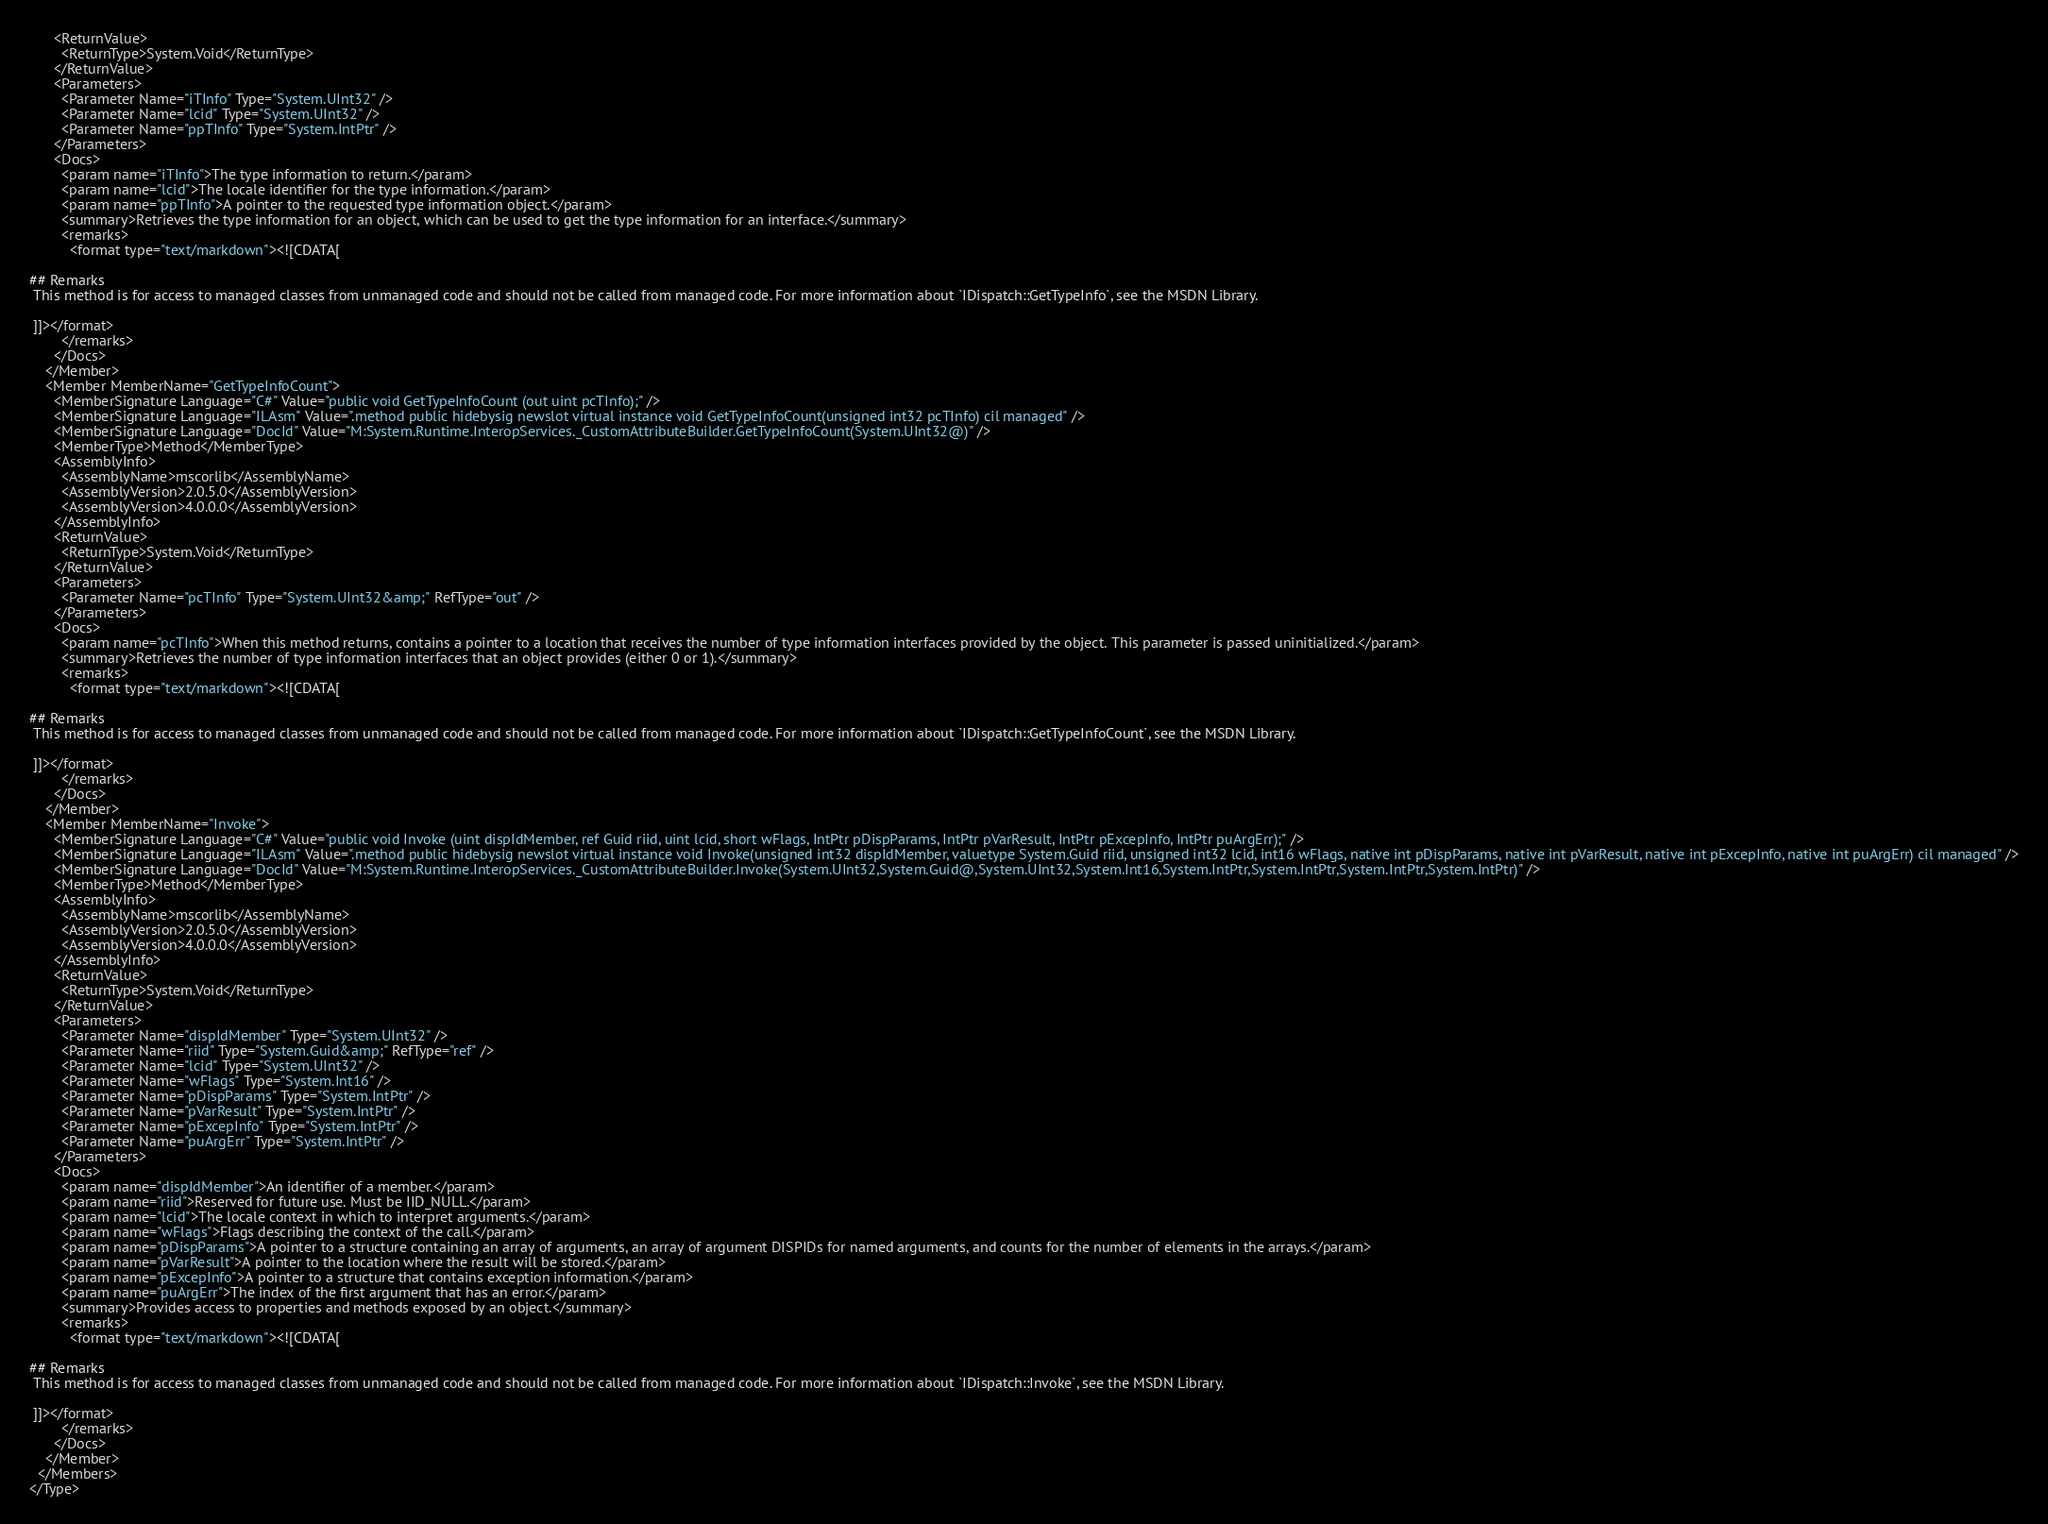Convert code to text. <code><loc_0><loc_0><loc_500><loc_500><_XML_>      <ReturnValue>
        <ReturnType>System.Void</ReturnType>
      </ReturnValue>
      <Parameters>
        <Parameter Name="iTInfo" Type="System.UInt32" />
        <Parameter Name="lcid" Type="System.UInt32" />
        <Parameter Name="ppTInfo" Type="System.IntPtr" />
      </Parameters>
      <Docs>
        <param name="iTInfo">The type information to return.</param>
        <param name="lcid">The locale identifier for the type information.</param>
        <param name="ppTInfo">A pointer to the requested type information object.</param>
        <summary>Retrieves the type information for an object, which can be used to get the type information for an interface.</summary>
        <remarks>
          <format type="text/markdown"><![CDATA[  
  
## Remarks  
 This method is for access to managed classes from unmanaged code and should not be called from managed code. For more information about `IDispatch::GetTypeInfo`, see the MSDN Library.  
  
 ]]></format>
        </remarks>
      </Docs>
    </Member>
    <Member MemberName="GetTypeInfoCount">
      <MemberSignature Language="C#" Value="public void GetTypeInfoCount (out uint pcTInfo);" />
      <MemberSignature Language="ILAsm" Value=".method public hidebysig newslot virtual instance void GetTypeInfoCount(unsigned int32 pcTInfo) cil managed" />
      <MemberSignature Language="DocId" Value="M:System.Runtime.InteropServices._CustomAttributeBuilder.GetTypeInfoCount(System.UInt32@)" />
      <MemberType>Method</MemberType>
      <AssemblyInfo>
        <AssemblyName>mscorlib</AssemblyName>
        <AssemblyVersion>2.0.5.0</AssemblyVersion>
        <AssemblyVersion>4.0.0.0</AssemblyVersion>
      </AssemblyInfo>
      <ReturnValue>
        <ReturnType>System.Void</ReturnType>
      </ReturnValue>
      <Parameters>
        <Parameter Name="pcTInfo" Type="System.UInt32&amp;" RefType="out" />
      </Parameters>
      <Docs>
        <param name="pcTInfo">When this method returns, contains a pointer to a location that receives the number of type information interfaces provided by the object. This parameter is passed uninitialized.</param>
        <summary>Retrieves the number of type information interfaces that an object provides (either 0 or 1).</summary>
        <remarks>
          <format type="text/markdown"><![CDATA[  
  
## Remarks  
 This method is for access to managed classes from unmanaged code and should not be called from managed code. For more information about `IDispatch::GetTypeInfoCount`, see the MSDN Library.  
  
 ]]></format>
        </remarks>
      </Docs>
    </Member>
    <Member MemberName="Invoke">
      <MemberSignature Language="C#" Value="public void Invoke (uint dispIdMember, ref Guid riid, uint lcid, short wFlags, IntPtr pDispParams, IntPtr pVarResult, IntPtr pExcepInfo, IntPtr puArgErr);" />
      <MemberSignature Language="ILAsm" Value=".method public hidebysig newslot virtual instance void Invoke(unsigned int32 dispIdMember, valuetype System.Guid riid, unsigned int32 lcid, int16 wFlags, native int pDispParams, native int pVarResult, native int pExcepInfo, native int puArgErr) cil managed" />
      <MemberSignature Language="DocId" Value="M:System.Runtime.InteropServices._CustomAttributeBuilder.Invoke(System.UInt32,System.Guid@,System.UInt32,System.Int16,System.IntPtr,System.IntPtr,System.IntPtr,System.IntPtr)" />
      <MemberType>Method</MemberType>
      <AssemblyInfo>
        <AssemblyName>mscorlib</AssemblyName>
        <AssemblyVersion>2.0.5.0</AssemblyVersion>
        <AssemblyVersion>4.0.0.0</AssemblyVersion>
      </AssemblyInfo>
      <ReturnValue>
        <ReturnType>System.Void</ReturnType>
      </ReturnValue>
      <Parameters>
        <Parameter Name="dispIdMember" Type="System.UInt32" />
        <Parameter Name="riid" Type="System.Guid&amp;" RefType="ref" />
        <Parameter Name="lcid" Type="System.UInt32" />
        <Parameter Name="wFlags" Type="System.Int16" />
        <Parameter Name="pDispParams" Type="System.IntPtr" />
        <Parameter Name="pVarResult" Type="System.IntPtr" />
        <Parameter Name="pExcepInfo" Type="System.IntPtr" />
        <Parameter Name="puArgErr" Type="System.IntPtr" />
      </Parameters>
      <Docs>
        <param name="dispIdMember">An identifier of a member.</param>
        <param name="riid">Reserved for future use. Must be IID_NULL.</param>
        <param name="lcid">The locale context in which to interpret arguments.</param>
        <param name="wFlags">Flags describing the context of the call.</param>
        <param name="pDispParams">A pointer to a structure containing an array of arguments, an array of argument DISPIDs for named arguments, and counts for the number of elements in the arrays.</param>
        <param name="pVarResult">A pointer to the location where the result will be stored.</param>
        <param name="pExcepInfo">A pointer to a structure that contains exception information.</param>
        <param name="puArgErr">The index of the first argument that has an error.</param>
        <summary>Provides access to properties and methods exposed by an object.</summary>
        <remarks>
          <format type="text/markdown"><![CDATA[  
  
## Remarks  
 This method is for access to managed classes from unmanaged code and should not be called from managed code. For more information about `IDispatch::Invoke`, see the MSDN Library.  
  
 ]]></format>
        </remarks>
      </Docs>
    </Member>
  </Members>
</Type>
</code> 